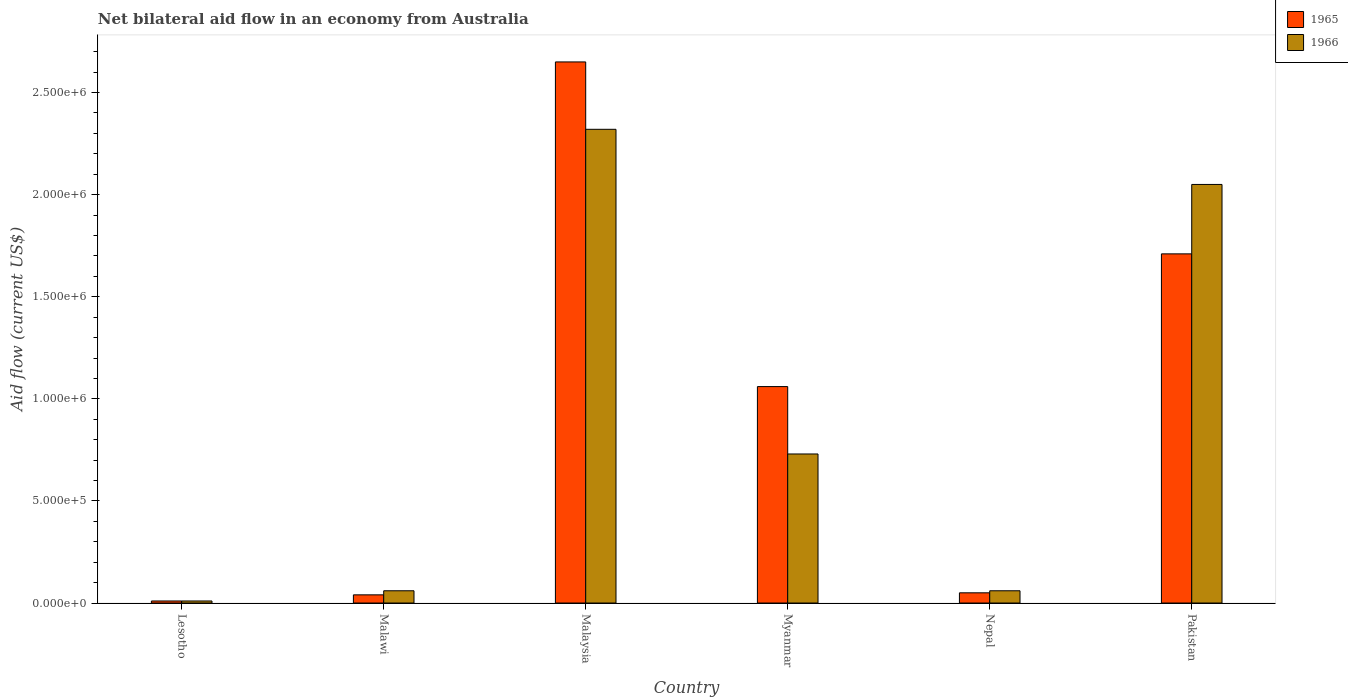How many groups of bars are there?
Your answer should be very brief. 6. How many bars are there on the 3rd tick from the left?
Keep it short and to the point. 2. How many bars are there on the 4th tick from the right?
Provide a short and direct response. 2. What is the label of the 5th group of bars from the left?
Give a very brief answer. Nepal. What is the net bilateral aid flow in 1966 in Malaysia?
Provide a short and direct response. 2.32e+06. Across all countries, what is the maximum net bilateral aid flow in 1965?
Offer a terse response. 2.65e+06. In which country was the net bilateral aid flow in 1966 maximum?
Keep it short and to the point. Malaysia. In which country was the net bilateral aid flow in 1966 minimum?
Provide a succinct answer. Lesotho. What is the total net bilateral aid flow in 1966 in the graph?
Offer a terse response. 5.23e+06. What is the difference between the net bilateral aid flow in 1965 in Lesotho and that in Malawi?
Offer a terse response. -3.00e+04. What is the difference between the net bilateral aid flow in 1966 in Nepal and the net bilateral aid flow in 1965 in Malaysia?
Your answer should be very brief. -2.59e+06. What is the average net bilateral aid flow in 1966 per country?
Provide a short and direct response. 8.72e+05. What is the difference between the net bilateral aid flow of/in 1965 and net bilateral aid flow of/in 1966 in Lesotho?
Ensure brevity in your answer.  0. In how many countries, is the net bilateral aid flow in 1966 greater than 2400000 US$?
Your answer should be very brief. 0. What is the ratio of the net bilateral aid flow in 1966 in Lesotho to that in Malaysia?
Your response must be concise. 0. What is the difference between the highest and the second highest net bilateral aid flow in 1965?
Your answer should be compact. 1.59e+06. What is the difference between the highest and the lowest net bilateral aid flow in 1966?
Ensure brevity in your answer.  2.31e+06. What does the 1st bar from the left in Malaysia represents?
Offer a terse response. 1965. What does the 2nd bar from the right in Lesotho represents?
Offer a terse response. 1965. How many bars are there?
Make the answer very short. 12. Are the values on the major ticks of Y-axis written in scientific E-notation?
Provide a short and direct response. Yes. Does the graph contain grids?
Ensure brevity in your answer.  No. Where does the legend appear in the graph?
Provide a succinct answer. Top right. How are the legend labels stacked?
Make the answer very short. Vertical. What is the title of the graph?
Give a very brief answer. Net bilateral aid flow in an economy from Australia. What is the Aid flow (current US$) of 1965 in Lesotho?
Offer a terse response. 10000. What is the Aid flow (current US$) in 1966 in Lesotho?
Keep it short and to the point. 10000. What is the Aid flow (current US$) of 1965 in Malawi?
Your response must be concise. 4.00e+04. What is the Aid flow (current US$) in 1965 in Malaysia?
Make the answer very short. 2.65e+06. What is the Aid flow (current US$) of 1966 in Malaysia?
Ensure brevity in your answer.  2.32e+06. What is the Aid flow (current US$) in 1965 in Myanmar?
Provide a short and direct response. 1.06e+06. What is the Aid flow (current US$) in 1966 in Myanmar?
Offer a very short reply. 7.30e+05. What is the Aid flow (current US$) in 1966 in Nepal?
Offer a terse response. 6.00e+04. What is the Aid flow (current US$) of 1965 in Pakistan?
Offer a terse response. 1.71e+06. What is the Aid flow (current US$) in 1966 in Pakistan?
Give a very brief answer. 2.05e+06. Across all countries, what is the maximum Aid flow (current US$) of 1965?
Provide a succinct answer. 2.65e+06. Across all countries, what is the maximum Aid flow (current US$) of 1966?
Keep it short and to the point. 2.32e+06. What is the total Aid flow (current US$) in 1965 in the graph?
Offer a terse response. 5.52e+06. What is the total Aid flow (current US$) in 1966 in the graph?
Provide a short and direct response. 5.23e+06. What is the difference between the Aid flow (current US$) in 1965 in Lesotho and that in Malaysia?
Your response must be concise. -2.64e+06. What is the difference between the Aid flow (current US$) of 1966 in Lesotho and that in Malaysia?
Offer a very short reply. -2.31e+06. What is the difference between the Aid flow (current US$) of 1965 in Lesotho and that in Myanmar?
Ensure brevity in your answer.  -1.05e+06. What is the difference between the Aid flow (current US$) in 1966 in Lesotho and that in Myanmar?
Provide a succinct answer. -7.20e+05. What is the difference between the Aid flow (current US$) of 1965 in Lesotho and that in Nepal?
Offer a terse response. -4.00e+04. What is the difference between the Aid flow (current US$) in 1965 in Lesotho and that in Pakistan?
Offer a terse response. -1.70e+06. What is the difference between the Aid flow (current US$) in 1966 in Lesotho and that in Pakistan?
Offer a terse response. -2.04e+06. What is the difference between the Aid flow (current US$) in 1965 in Malawi and that in Malaysia?
Keep it short and to the point. -2.61e+06. What is the difference between the Aid flow (current US$) of 1966 in Malawi and that in Malaysia?
Your response must be concise. -2.26e+06. What is the difference between the Aid flow (current US$) of 1965 in Malawi and that in Myanmar?
Offer a terse response. -1.02e+06. What is the difference between the Aid flow (current US$) in 1966 in Malawi and that in Myanmar?
Your response must be concise. -6.70e+05. What is the difference between the Aid flow (current US$) in 1965 in Malawi and that in Nepal?
Make the answer very short. -10000. What is the difference between the Aid flow (current US$) in 1966 in Malawi and that in Nepal?
Your answer should be compact. 0. What is the difference between the Aid flow (current US$) of 1965 in Malawi and that in Pakistan?
Your response must be concise. -1.67e+06. What is the difference between the Aid flow (current US$) in 1966 in Malawi and that in Pakistan?
Offer a terse response. -1.99e+06. What is the difference between the Aid flow (current US$) in 1965 in Malaysia and that in Myanmar?
Ensure brevity in your answer.  1.59e+06. What is the difference between the Aid flow (current US$) in 1966 in Malaysia and that in Myanmar?
Offer a terse response. 1.59e+06. What is the difference between the Aid flow (current US$) of 1965 in Malaysia and that in Nepal?
Make the answer very short. 2.60e+06. What is the difference between the Aid flow (current US$) in 1966 in Malaysia and that in Nepal?
Your answer should be very brief. 2.26e+06. What is the difference between the Aid flow (current US$) in 1965 in Malaysia and that in Pakistan?
Make the answer very short. 9.40e+05. What is the difference between the Aid flow (current US$) of 1965 in Myanmar and that in Nepal?
Give a very brief answer. 1.01e+06. What is the difference between the Aid flow (current US$) in 1966 in Myanmar and that in Nepal?
Your answer should be very brief. 6.70e+05. What is the difference between the Aid flow (current US$) of 1965 in Myanmar and that in Pakistan?
Provide a short and direct response. -6.50e+05. What is the difference between the Aid flow (current US$) of 1966 in Myanmar and that in Pakistan?
Give a very brief answer. -1.32e+06. What is the difference between the Aid flow (current US$) in 1965 in Nepal and that in Pakistan?
Your answer should be compact. -1.66e+06. What is the difference between the Aid flow (current US$) of 1966 in Nepal and that in Pakistan?
Your answer should be very brief. -1.99e+06. What is the difference between the Aid flow (current US$) of 1965 in Lesotho and the Aid flow (current US$) of 1966 in Malaysia?
Give a very brief answer. -2.31e+06. What is the difference between the Aid flow (current US$) of 1965 in Lesotho and the Aid flow (current US$) of 1966 in Myanmar?
Your answer should be compact. -7.20e+05. What is the difference between the Aid flow (current US$) of 1965 in Lesotho and the Aid flow (current US$) of 1966 in Nepal?
Offer a terse response. -5.00e+04. What is the difference between the Aid flow (current US$) of 1965 in Lesotho and the Aid flow (current US$) of 1966 in Pakistan?
Provide a succinct answer. -2.04e+06. What is the difference between the Aid flow (current US$) in 1965 in Malawi and the Aid flow (current US$) in 1966 in Malaysia?
Your answer should be compact. -2.28e+06. What is the difference between the Aid flow (current US$) of 1965 in Malawi and the Aid flow (current US$) of 1966 in Myanmar?
Your answer should be compact. -6.90e+05. What is the difference between the Aid flow (current US$) of 1965 in Malawi and the Aid flow (current US$) of 1966 in Pakistan?
Provide a short and direct response. -2.01e+06. What is the difference between the Aid flow (current US$) of 1965 in Malaysia and the Aid flow (current US$) of 1966 in Myanmar?
Make the answer very short. 1.92e+06. What is the difference between the Aid flow (current US$) of 1965 in Malaysia and the Aid flow (current US$) of 1966 in Nepal?
Provide a succinct answer. 2.59e+06. What is the difference between the Aid flow (current US$) in 1965 in Myanmar and the Aid flow (current US$) in 1966 in Nepal?
Give a very brief answer. 1.00e+06. What is the difference between the Aid flow (current US$) of 1965 in Myanmar and the Aid flow (current US$) of 1966 in Pakistan?
Keep it short and to the point. -9.90e+05. What is the difference between the Aid flow (current US$) in 1965 in Nepal and the Aid flow (current US$) in 1966 in Pakistan?
Offer a terse response. -2.00e+06. What is the average Aid flow (current US$) of 1965 per country?
Ensure brevity in your answer.  9.20e+05. What is the average Aid flow (current US$) of 1966 per country?
Your answer should be very brief. 8.72e+05. What is the difference between the Aid flow (current US$) of 1965 and Aid flow (current US$) of 1966 in Lesotho?
Ensure brevity in your answer.  0. What is the difference between the Aid flow (current US$) in 1965 and Aid flow (current US$) in 1966 in Malawi?
Your answer should be very brief. -2.00e+04. What is the ratio of the Aid flow (current US$) in 1965 in Lesotho to that in Malawi?
Provide a succinct answer. 0.25. What is the ratio of the Aid flow (current US$) in 1965 in Lesotho to that in Malaysia?
Give a very brief answer. 0. What is the ratio of the Aid flow (current US$) in 1966 in Lesotho to that in Malaysia?
Keep it short and to the point. 0. What is the ratio of the Aid flow (current US$) of 1965 in Lesotho to that in Myanmar?
Make the answer very short. 0.01. What is the ratio of the Aid flow (current US$) of 1966 in Lesotho to that in Myanmar?
Provide a succinct answer. 0.01. What is the ratio of the Aid flow (current US$) in 1965 in Lesotho to that in Nepal?
Your answer should be very brief. 0.2. What is the ratio of the Aid flow (current US$) of 1965 in Lesotho to that in Pakistan?
Provide a succinct answer. 0.01. What is the ratio of the Aid flow (current US$) of 1966 in Lesotho to that in Pakistan?
Keep it short and to the point. 0. What is the ratio of the Aid flow (current US$) of 1965 in Malawi to that in Malaysia?
Your response must be concise. 0.02. What is the ratio of the Aid flow (current US$) of 1966 in Malawi to that in Malaysia?
Offer a very short reply. 0.03. What is the ratio of the Aid flow (current US$) of 1965 in Malawi to that in Myanmar?
Offer a terse response. 0.04. What is the ratio of the Aid flow (current US$) of 1966 in Malawi to that in Myanmar?
Your answer should be very brief. 0.08. What is the ratio of the Aid flow (current US$) of 1965 in Malawi to that in Nepal?
Give a very brief answer. 0.8. What is the ratio of the Aid flow (current US$) in 1966 in Malawi to that in Nepal?
Keep it short and to the point. 1. What is the ratio of the Aid flow (current US$) of 1965 in Malawi to that in Pakistan?
Provide a succinct answer. 0.02. What is the ratio of the Aid flow (current US$) of 1966 in Malawi to that in Pakistan?
Your response must be concise. 0.03. What is the ratio of the Aid flow (current US$) of 1965 in Malaysia to that in Myanmar?
Provide a succinct answer. 2.5. What is the ratio of the Aid flow (current US$) of 1966 in Malaysia to that in Myanmar?
Your answer should be compact. 3.18. What is the ratio of the Aid flow (current US$) in 1966 in Malaysia to that in Nepal?
Your answer should be very brief. 38.67. What is the ratio of the Aid flow (current US$) in 1965 in Malaysia to that in Pakistan?
Keep it short and to the point. 1.55. What is the ratio of the Aid flow (current US$) of 1966 in Malaysia to that in Pakistan?
Your response must be concise. 1.13. What is the ratio of the Aid flow (current US$) of 1965 in Myanmar to that in Nepal?
Provide a short and direct response. 21.2. What is the ratio of the Aid flow (current US$) of 1966 in Myanmar to that in Nepal?
Keep it short and to the point. 12.17. What is the ratio of the Aid flow (current US$) in 1965 in Myanmar to that in Pakistan?
Offer a terse response. 0.62. What is the ratio of the Aid flow (current US$) in 1966 in Myanmar to that in Pakistan?
Your response must be concise. 0.36. What is the ratio of the Aid flow (current US$) of 1965 in Nepal to that in Pakistan?
Provide a short and direct response. 0.03. What is the ratio of the Aid flow (current US$) of 1966 in Nepal to that in Pakistan?
Provide a succinct answer. 0.03. What is the difference between the highest and the second highest Aid flow (current US$) in 1965?
Make the answer very short. 9.40e+05. What is the difference between the highest and the lowest Aid flow (current US$) in 1965?
Provide a short and direct response. 2.64e+06. What is the difference between the highest and the lowest Aid flow (current US$) of 1966?
Provide a short and direct response. 2.31e+06. 